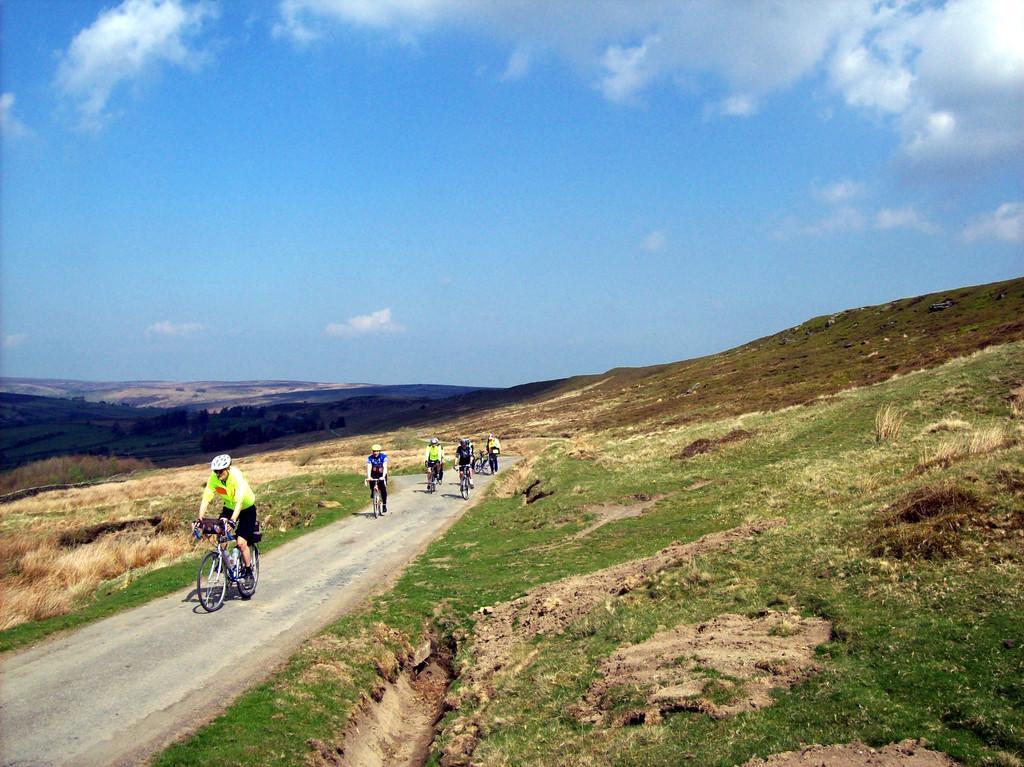Please provide a concise description of this image. In this image I see the hills and I see few people who are on the cycles and I see the path. In the background I see the clear sky. 